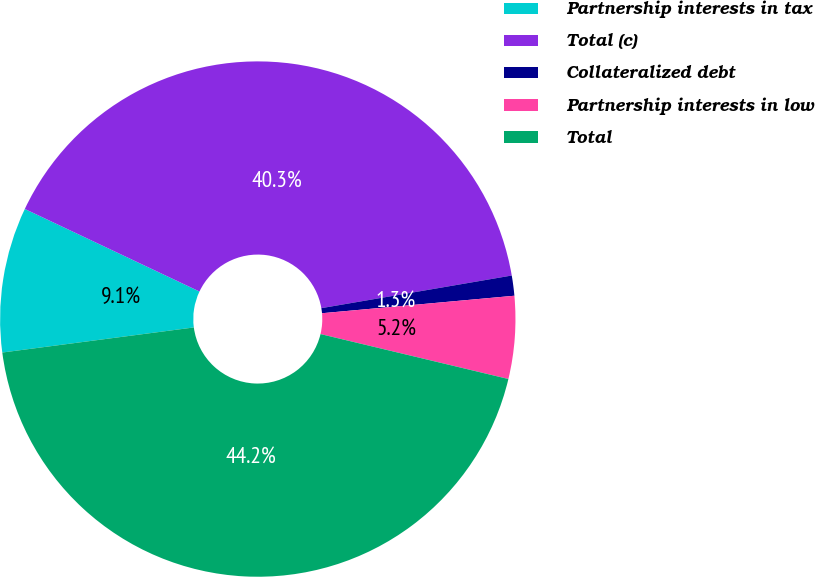Convert chart. <chart><loc_0><loc_0><loc_500><loc_500><pie_chart><fcel>Partnership interests in tax<fcel>Total (c)<fcel>Collateralized debt<fcel>Partnership interests in low<fcel>Total<nl><fcel>9.1%<fcel>40.27%<fcel>1.26%<fcel>5.18%<fcel>44.19%<nl></chart> 